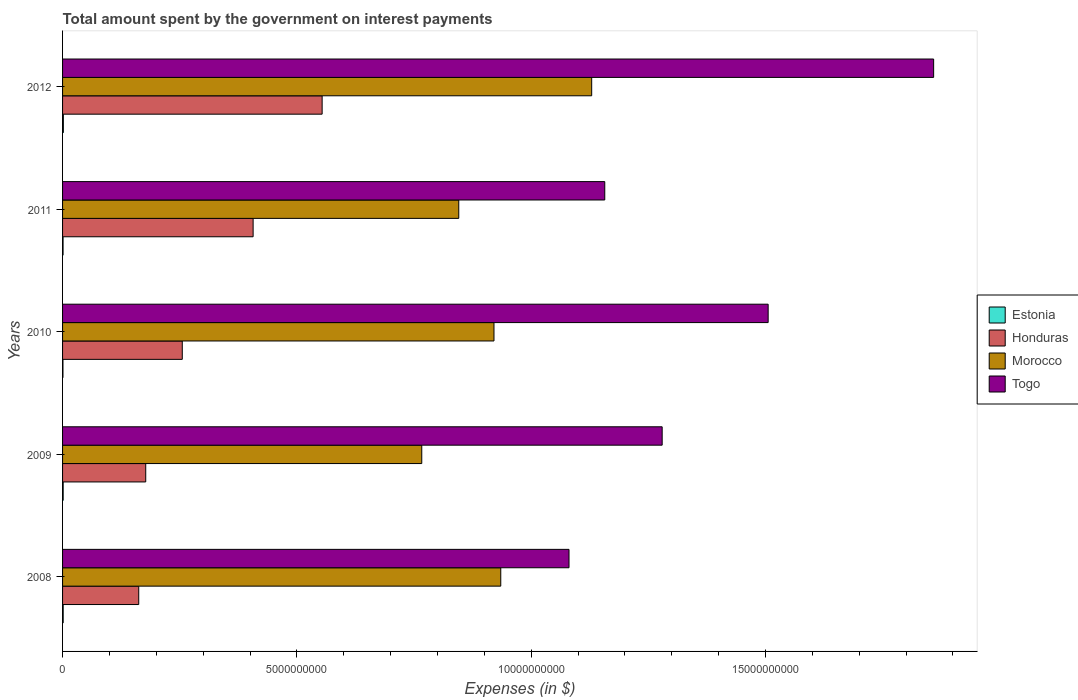How many different coloured bars are there?
Offer a terse response. 4. Are the number of bars per tick equal to the number of legend labels?
Ensure brevity in your answer.  Yes. Are the number of bars on each tick of the Y-axis equal?
Provide a short and direct response. Yes. How many bars are there on the 4th tick from the bottom?
Provide a short and direct response. 4. What is the label of the 4th group of bars from the top?
Offer a very short reply. 2009. In how many cases, is the number of bars for a given year not equal to the number of legend labels?
Provide a short and direct response. 0. What is the amount spent on interest payments by the government in Togo in 2012?
Keep it short and to the point. 1.86e+1. Across all years, what is the maximum amount spent on interest payments by the government in Morocco?
Your response must be concise. 1.13e+1. Across all years, what is the minimum amount spent on interest payments by the government in Estonia?
Provide a short and direct response. 8.20e+06. What is the total amount spent on interest payments by the government in Honduras in the graph?
Your response must be concise. 1.56e+1. What is the difference between the amount spent on interest payments by the government in Togo in 2009 and that in 2010?
Provide a short and direct response. -2.26e+09. What is the difference between the amount spent on interest payments by the government in Honduras in 2011 and the amount spent on interest payments by the government in Estonia in 2012?
Ensure brevity in your answer.  4.05e+09. What is the average amount spent on interest payments by the government in Morocco per year?
Make the answer very short. 9.19e+09. In the year 2011, what is the difference between the amount spent on interest payments by the government in Morocco and amount spent on interest payments by the government in Honduras?
Offer a very short reply. 4.39e+09. In how many years, is the amount spent on interest payments by the government in Morocco greater than 13000000000 $?
Ensure brevity in your answer.  0. What is the ratio of the amount spent on interest payments by the government in Morocco in 2010 to that in 2011?
Give a very brief answer. 1.09. Is the difference between the amount spent on interest payments by the government in Morocco in 2010 and 2011 greater than the difference between the amount spent on interest payments by the government in Honduras in 2010 and 2011?
Make the answer very short. Yes. What is the difference between the highest and the second highest amount spent on interest payments by the government in Togo?
Your answer should be compact. 3.53e+09. What is the difference between the highest and the lowest amount spent on interest payments by the government in Togo?
Provide a succinct answer. 7.78e+09. Is it the case that in every year, the sum of the amount spent on interest payments by the government in Morocco and amount spent on interest payments by the government in Togo is greater than the sum of amount spent on interest payments by the government in Estonia and amount spent on interest payments by the government in Honduras?
Offer a terse response. Yes. What does the 1st bar from the top in 2012 represents?
Offer a very short reply. Togo. What does the 4th bar from the bottom in 2012 represents?
Provide a succinct answer. Togo. How many bars are there?
Your answer should be compact. 20. How many years are there in the graph?
Make the answer very short. 5. Does the graph contain grids?
Your answer should be compact. No. What is the title of the graph?
Your answer should be very brief. Total amount spent by the government on interest payments. Does "Belize" appear as one of the legend labels in the graph?
Make the answer very short. No. What is the label or title of the X-axis?
Offer a terse response. Expenses (in $). What is the label or title of the Y-axis?
Ensure brevity in your answer.  Years. What is the Expenses (in $) in Estonia in 2008?
Keep it short and to the point. 1.32e+07. What is the Expenses (in $) of Honduras in 2008?
Offer a terse response. 1.63e+09. What is the Expenses (in $) in Morocco in 2008?
Make the answer very short. 9.35e+09. What is the Expenses (in $) in Togo in 2008?
Offer a very short reply. 1.08e+1. What is the Expenses (in $) of Estonia in 2009?
Make the answer very short. 1.28e+07. What is the Expenses (in $) of Honduras in 2009?
Make the answer very short. 1.77e+09. What is the Expenses (in $) of Morocco in 2009?
Offer a very short reply. 7.66e+09. What is the Expenses (in $) in Togo in 2009?
Provide a succinct answer. 1.28e+1. What is the Expenses (in $) of Estonia in 2010?
Keep it short and to the point. 8.20e+06. What is the Expenses (in $) in Honduras in 2010?
Give a very brief answer. 2.55e+09. What is the Expenses (in $) of Morocco in 2010?
Your answer should be compact. 9.21e+09. What is the Expenses (in $) of Togo in 2010?
Your response must be concise. 1.51e+1. What is the Expenses (in $) of Estonia in 2011?
Ensure brevity in your answer.  1.07e+07. What is the Expenses (in $) of Honduras in 2011?
Offer a very short reply. 4.07e+09. What is the Expenses (in $) of Morocco in 2011?
Your answer should be very brief. 8.45e+09. What is the Expenses (in $) of Togo in 2011?
Ensure brevity in your answer.  1.16e+1. What is the Expenses (in $) of Estonia in 2012?
Keep it short and to the point. 1.70e+07. What is the Expenses (in $) of Honduras in 2012?
Your answer should be compact. 5.54e+09. What is the Expenses (in $) of Morocco in 2012?
Keep it short and to the point. 1.13e+1. What is the Expenses (in $) of Togo in 2012?
Give a very brief answer. 1.86e+1. Across all years, what is the maximum Expenses (in $) of Estonia?
Offer a very short reply. 1.70e+07. Across all years, what is the maximum Expenses (in $) in Honduras?
Make the answer very short. 5.54e+09. Across all years, what is the maximum Expenses (in $) of Morocco?
Ensure brevity in your answer.  1.13e+1. Across all years, what is the maximum Expenses (in $) of Togo?
Your answer should be very brief. 1.86e+1. Across all years, what is the minimum Expenses (in $) in Estonia?
Ensure brevity in your answer.  8.20e+06. Across all years, what is the minimum Expenses (in $) of Honduras?
Your response must be concise. 1.63e+09. Across all years, what is the minimum Expenses (in $) in Morocco?
Make the answer very short. 7.66e+09. Across all years, what is the minimum Expenses (in $) in Togo?
Provide a succinct answer. 1.08e+1. What is the total Expenses (in $) in Estonia in the graph?
Your response must be concise. 6.19e+07. What is the total Expenses (in $) in Honduras in the graph?
Give a very brief answer. 1.56e+1. What is the total Expenses (in $) of Morocco in the graph?
Your response must be concise. 4.60e+1. What is the total Expenses (in $) of Togo in the graph?
Offer a very short reply. 6.88e+1. What is the difference between the Expenses (in $) in Estonia in 2008 and that in 2009?
Offer a terse response. 4.00e+05. What is the difference between the Expenses (in $) in Honduras in 2008 and that in 2009?
Your answer should be very brief. -1.49e+08. What is the difference between the Expenses (in $) of Morocco in 2008 and that in 2009?
Provide a succinct answer. 1.69e+09. What is the difference between the Expenses (in $) in Togo in 2008 and that in 2009?
Ensure brevity in your answer.  -1.99e+09. What is the difference between the Expenses (in $) of Honduras in 2008 and that in 2010?
Ensure brevity in your answer.  -9.29e+08. What is the difference between the Expenses (in $) in Morocco in 2008 and that in 2010?
Make the answer very short. 1.45e+08. What is the difference between the Expenses (in $) in Togo in 2008 and that in 2010?
Ensure brevity in your answer.  -4.25e+09. What is the difference between the Expenses (in $) of Estonia in 2008 and that in 2011?
Offer a terse response. 2.50e+06. What is the difference between the Expenses (in $) in Honduras in 2008 and that in 2011?
Offer a very short reply. -2.44e+09. What is the difference between the Expenses (in $) of Morocco in 2008 and that in 2011?
Your answer should be very brief. 8.96e+08. What is the difference between the Expenses (in $) in Togo in 2008 and that in 2011?
Provide a succinct answer. -7.63e+08. What is the difference between the Expenses (in $) in Estonia in 2008 and that in 2012?
Your response must be concise. -3.80e+06. What is the difference between the Expenses (in $) in Honduras in 2008 and that in 2012?
Provide a short and direct response. -3.91e+09. What is the difference between the Expenses (in $) in Morocco in 2008 and that in 2012?
Your answer should be compact. -1.94e+09. What is the difference between the Expenses (in $) of Togo in 2008 and that in 2012?
Keep it short and to the point. -7.78e+09. What is the difference between the Expenses (in $) of Estonia in 2009 and that in 2010?
Make the answer very short. 4.60e+06. What is the difference between the Expenses (in $) in Honduras in 2009 and that in 2010?
Your answer should be compact. -7.80e+08. What is the difference between the Expenses (in $) of Morocco in 2009 and that in 2010?
Ensure brevity in your answer.  -1.54e+09. What is the difference between the Expenses (in $) of Togo in 2009 and that in 2010?
Your answer should be compact. -2.26e+09. What is the difference between the Expenses (in $) in Estonia in 2009 and that in 2011?
Provide a short and direct response. 2.10e+06. What is the difference between the Expenses (in $) of Honduras in 2009 and that in 2011?
Make the answer very short. -2.29e+09. What is the difference between the Expenses (in $) of Morocco in 2009 and that in 2011?
Offer a very short reply. -7.90e+08. What is the difference between the Expenses (in $) of Togo in 2009 and that in 2011?
Give a very brief answer. 1.22e+09. What is the difference between the Expenses (in $) in Estonia in 2009 and that in 2012?
Keep it short and to the point. -4.20e+06. What is the difference between the Expenses (in $) of Honduras in 2009 and that in 2012?
Your answer should be very brief. -3.76e+09. What is the difference between the Expenses (in $) in Morocco in 2009 and that in 2012?
Your answer should be very brief. -3.63e+09. What is the difference between the Expenses (in $) of Togo in 2009 and that in 2012?
Provide a short and direct response. -5.79e+09. What is the difference between the Expenses (in $) in Estonia in 2010 and that in 2011?
Keep it short and to the point. -2.50e+06. What is the difference between the Expenses (in $) of Honduras in 2010 and that in 2011?
Your response must be concise. -1.51e+09. What is the difference between the Expenses (in $) in Morocco in 2010 and that in 2011?
Your answer should be very brief. 7.52e+08. What is the difference between the Expenses (in $) of Togo in 2010 and that in 2011?
Make the answer very short. 3.49e+09. What is the difference between the Expenses (in $) in Estonia in 2010 and that in 2012?
Your response must be concise. -8.80e+06. What is the difference between the Expenses (in $) in Honduras in 2010 and that in 2012?
Offer a terse response. -2.98e+09. What is the difference between the Expenses (in $) of Morocco in 2010 and that in 2012?
Your answer should be compact. -2.08e+09. What is the difference between the Expenses (in $) in Togo in 2010 and that in 2012?
Your answer should be compact. -3.53e+09. What is the difference between the Expenses (in $) in Estonia in 2011 and that in 2012?
Offer a terse response. -6.30e+06. What is the difference between the Expenses (in $) of Honduras in 2011 and that in 2012?
Your response must be concise. -1.47e+09. What is the difference between the Expenses (in $) of Morocco in 2011 and that in 2012?
Your answer should be compact. -2.84e+09. What is the difference between the Expenses (in $) in Togo in 2011 and that in 2012?
Provide a succinct answer. -7.02e+09. What is the difference between the Expenses (in $) of Estonia in 2008 and the Expenses (in $) of Honduras in 2009?
Offer a terse response. -1.76e+09. What is the difference between the Expenses (in $) in Estonia in 2008 and the Expenses (in $) in Morocco in 2009?
Offer a terse response. -7.65e+09. What is the difference between the Expenses (in $) in Estonia in 2008 and the Expenses (in $) in Togo in 2009?
Provide a succinct answer. -1.28e+1. What is the difference between the Expenses (in $) of Honduras in 2008 and the Expenses (in $) of Morocco in 2009?
Keep it short and to the point. -6.04e+09. What is the difference between the Expenses (in $) in Honduras in 2008 and the Expenses (in $) in Togo in 2009?
Your answer should be very brief. -1.12e+1. What is the difference between the Expenses (in $) of Morocco in 2008 and the Expenses (in $) of Togo in 2009?
Offer a very short reply. -3.44e+09. What is the difference between the Expenses (in $) of Estonia in 2008 and the Expenses (in $) of Honduras in 2010?
Offer a terse response. -2.54e+09. What is the difference between the Expenses (in $) in Estonia in 2008 and the Expenses (in $) in Morocco in 2010?
Keep it short and to the point. -9.19e+09. What is the difference between the Expenses (in $) in Estonia in 2008 and the Expenses (in $) in Togo in 2010?
Give a very brief answer. -1.50e+1. What is the difference between the Expenses (in $) in Honduras in 2008 and the Expenses (in $) in Morocco in 2010?
Ensure brevity in your answer.  -7.58e+09. What is the difference between the Expenses (in $) in Honduras in 2008 and the Expenses (in $) in Togo in 2010?
Your response must be concise. -1.34e+1. What is the difference between the Expenses (in $) in Morocco in 2008 and the Expenses (in $) in Togo in 2010?
Make the answer very short. -5.71e+09. What is the difference between the Expenses (in $) in Estonia in 2008 and the Expenses (in $) in Honduras in 2011?
Offer a terse response. -4.05e+09. What is the difference between the Expenses (in $) of Estonia in 2008 and the Expenses (in $) of Morocco in 2011?
Provide a succinct answer. -8.44e+09. What is the difference between the Expenses (in $) in Estonia in 2008 and the Expenses (in $) in Togo in 2011?
Your answer should be very brief. -1.16e+1. What is the difference between the Expenses (in $) of Honduras in 2008 and the Expenses (in $) of Morocco in 2011?
Ensure brevity in your answer.  -6.83e+09. What is the difference between the Expenses (in $) in Honduras in 2008 and the Expenses (in $) in Togo in 2011?
Offer a terse response. -9.94e+09. What is the difference between the Expenses (in $) of Morocco in 2008 and the Expenses (in $) of Togo in 2011?
Provide a short and direct response. -2.22e+09. What is the difference between the Expenses (in $) in Estonia in 2008 and the Expenses (in $) in Honduras in 2012?
Your answer should be very brief. -5.53e+09. What is the difference between the Expenses (in $) of Estonia in 2008 and the Expenses (in $) of Morocco in 2012?
Make the answer very short. -1.13e+1. What is the difference between the Expenses (in $) of Estonia in 2008 and the Expenses (in $) of Togo in 2012?
Provide a short and direct response. -1.86e+1. What is the difference between the Expenses (in $) of Honduras in 2008 and the Expenses (in $) of Morocco in 2012?
Offer a terse response. -9.67e+09. What is the difference between the Expenses (in $) in Honduras in 2008 and the Expenses (in $) in Togo in 2012?
Provide a succinct answer. -1.70e+1. What is the difference between the Expenses (in $) in Morocco in 2008 and the Expenses (in $) in Togo in 2012?
Offer a very short reply. -9.24e+09. What is the difference between the Expenses (in $) in Estonia in 2009 and the Expenses (in $) in Honduras in 2010?
Make the answer very short. -2.54e+09. What is the difference between the Expenses (in $) of Estonia in 2009 and the Expenses (in $) of Morocco in 2010?
Provide a short and direct response. -9.19e+09. What is the difference between the Expenses (in $) of Estonia in 2009 and the Expenses (in $) of Togo in 2010?
Offer a terse response. -1.50e+1. What is the difference between the Expenses (in $) of Honduras in 2009 and the Expenses (in $) of Morocco in 2010?
Offer a very short reply. -7.43e+09. What is the difference between the Expenses (in $) of Honduras in 2009 and the Expenses (in $) of Togo in 2010?
Offer a terse response. -1.33e+1. What is the difference between the Expenses (in $) in Morocco in 2009 and the Expenses (in $) in Togo in 2010?
Your response must be concise. -7.39e+09. What is the difference between the Expenses (in $) in Estonia in 2009 and the Expenses (in $) in Honduras in 2011?
Your response must be concise. -4.05e+09. What is the difference between the Expenses (in $) of Estonia in 2009 and the Expenses (in $) of Morocco in 2011?
Keep it short and to the point. -8.44e+09. What is the difference between the Expenses (in $) in Estonia in 2009 and the Expenses (in $) in Togo in 2011?
Make the answer very short. -1.16e+1. What is the difference between the Expenses (in $) in Honduras in 2009 and the Expenses (in $) in Morocco in 2011?
Offer a very short reply. -6.68e+09. What is the difference between the Expenses (in $) in Honduras in 2009 and the Expenses (in $) in Togo in 2011?
Provide a succinct answer. -9.80e+09. What is the difference between the Expenses (in $) of Morocco in 2009 and the Expenses (in $) of Togo in 2011?
Your response must be concise. -3.91e+09. What is the difference between the Expenses (in $) of Estonia in 2009 and the Expenses (in $) of Honduras in 2012?
Your response must be concise. -5.53e+09. What is the difference between the Expenses (in $) in Estonia in 2009 and the Expenses (in $) in Morocco in 2012?
Offer a terse response. -1.13e+1. What is the difference between the Expenses (in $) in Estonia in 2009 and the Expenses (in $) in Togo in 2012?
Your answer should be very brief. -1.86e+1. What is the difference between the Expenses (in $) of Honduras in 2009 and the Expenses (in $) of Morocco in 2012?
Offer a very short reply. -9.52e+09. What is the difference between the Expenses (in $) of Honduras in 2009 and the Expenses (in $) of Togo in 2012?
Provide a short and direct response. -1.68e+1. What is the difference between the Expenses (in $) of Morocco in 2009 and the Expenses (in $) of Togo in 2012?
Make the answer very short. -1.09e+1. What is the difference between the Expenses (in $) in Estonia in 2010 and the Expenses (in $) in Honduras in 2011?
Offer a terse response. -4.06e+09. What is the difference between the Expenses (in $) in Estonia in 2010 and the Expenses (in $) in Morocco in 2011?
Give a very brief answer. -8.45e+09. What is the difference between the Expenses (in $) of Estonia in 2010 and the Expenses (in $) of Togo in 2011?
Provide a short and direct response. -1.16e+1. What is the difference between the Expenses (in $) in Honduras in 2010 and the Expenses (in $) in Morocco in 2011?
Your answer should be very brief. -5.90e+09. What is the difference between the Expenses (in $) of Honduras in 2010 and the Expenses (in $) of Togo in 2011?
Offer a terse response. -9.02e+09. What is the difference between the Expenses (in $) of Morocco in 2010 and the Expenses (in $) of Togo in 2011?
Offer a very short reply. -2.36e+09. What is the difference between the Expenses (in $) in Estonia in 2010 and the Expenses (in $) in Honduras in 2012?
Your answer should be very brief. -5.53e+09. What is the difference between the Expenses (in $) in Estonia in 2010 and the Expenses (in $) in Morocco in 2012?
Ensure brevity in your answer.  -1.13e+1. What is the difference between the Expenses (in $) in Estonia in 2010 and the Expenses (in $) in Togo in 2012?
Your answer should be very brief. -1.86e+1. What is the difference between the Expenses (in $) of Honduras in 2010 and the Expenses (in $) of Morocco in 2012?
Give a very brief answer. -8.74e+09. What is the difference between the Expenses (in $) in Honduras in 2010 and the Expenses (in $) in Togo in 2012?
Your response must be concise. -1.60e+1. What is the difference between the Expenses (in $) of Morocco in 2010 and the Expenses (in $) of Togo in 2012?
Your answer should be compact. -9.38e+09. What is the difference between the Expenses (in $) in Estonia in 2011 and the Expenses (in $) in Honduras in 2012?
Keep it short and to the point. -5.53e+09. What is the difference between the Expenses (in $) in Estonia in 2011 and the Expenses (in $) in Morocco in 2012?
Ensure brevity in your answer.  -1.13e+1. What is the difference between the Expenses (in $) in Estonia in 2011 and the Expenses (in $) in Togo in 2012?
Make the answer very short. -1.86e+1. What is the difference between the Expenses (in $) in Honduras in 2011 and the Expenses (in $) in Morocco in 2012?
Provide a succinct answer. -7.22e+09. What is the difference between the Expenses (in $) of Honduras in 2011 and the Expenses (in $) of Togo in 2012?
Make the answer very short. -1.45e+1. What is the difference between the Expenses (in $) in Morocco in 2011 and the Expenses (in $) in Togo in 2012?
Offer a very short reply. -1.01e+1. What is the average Expenses (in $) of Estonia per year?
Make the answer very short. 1.24e+07. What is the average Expenses (in $) of Honduras per year?
Give a very brief answer. 3.11e+09. What is the average Expenses (in $) in Morocco per year?
Ensure brevity in your answer.  9.19e+09. What is the average Expenses (in $) of Togo per year?
Your answer should be very brief. 1.38e+1. In the year 2008, what is the difference between the Expenses (in $) of Estonia and Expenses (in $) of Honduras?
Provide a succinct answer. -1.61e+09. In the year 2008, what is the difference between the Expenses (in $) in Estonia and Expenses (in $) in Morocco?
Offer a very short reply. -9.34e+09. In the year 2008, what is the difference between the Expenses (in $) of Estonia and Expenses (in $) of Togo?
Keep it short and to the point. -1.08e+1. In the year 2008, what is the difference between the Expenses (in $) of Honduras and Expenses (in $) of Morocco?
Your response must be concise. -7.73e+09. In the year 2008, what is the difference between the Expenses (in $) of Honduras and Expenses (in $) of Togo?
Keep it short and to the point. -9.18e+09. In the year 2008, what is the difference between the Expenses (in $) in Morocco and Expenses (in $) in Togo?
Your answer should be very brief. -1.46e+09. In the year 2009, what is the difference between the Expenses (in $) of Estonia and Expenses (in $) of Honduras?
Offer a terse response. -1.76e+09. In the year 2009, what is the difference between the Expenses (in $) of Estonia and Expenses (in $) of Morocco?
Your response must be concise. -7.65e+09. In the year 2009, what is the difference between the Expenses (in $) of Estonia and Expenses (in $) of Togo?
Provide a short and direct response. -1.28e+1. In the year 2009, what is the difference between the Expenses (in $) of Honduras and Expenses (in $) of Morocco?
Your response must be concise. -5.89e+09. In the year 2009, what is the difference between the Expenses (in $) of Honduras and Expenses (in $) of Togo?
Make the answer very short. -1.10e+1. In the year 2009, what is the difference between the Expenses (in $) of Morocco and Expenses (in $) of Togo?
Provide a short and direct response. -5.13e+09. In the year 2010, what is the difference between the Expenses (in $) of Estonia and Expenses (in $) of Honduras?
Your answer should be compact. -2.55e+09. In the year 2010, what is the difference between the Expenses (in $) of Estonia and Expenses (in $) of Morocco?
Make the answer very short. -9.20e+09. In the year 2010, what is the difference between the Expenses (in $) of Estonia and Expenses (in $) of Togo?
Give a very brief answer. -1.50e+1. In the year 2010, what is the difference between the Expenses (in $) of Honduras and Expenses (in $) of Morocco?
Provide a short and direct response. -6.65e+09. In the year 2010, what is the difference between the Expenses (in $) of Honduras and Expenses (in $) of Togo?
Ensure brevity in your answer.  -1.25e+1. In the year 2010, what is the difference between the Expenses (in $) in Morocco and Expenses (in $) in Togo?
Offer a terse response. -5.85e+09. In the year 2011, what is the difference between the Expenses (in $) in Estonia and Expenses (in $) in Honduras?
Keep it short and to the point. -4.06e+09. In the year 2011, what is the difference between the Expenses (in $) of Estonia and Expenses (in $) of Morocco?
Your answer should be very brief. -8.44e+09. In the year 2011, what is the difference between the Expenses (in $) of Estonia and Expenses (in $) of Togo?
Ensure brevity in your answer.  -1.16e+1. In the year 2011, what is the difference between the Expenses (in $) in Honduras and Expenses (in $) in Morocco?
Give a very brief answer. -4.39e+09. In the year 2011, what is the difference between the Expenses (in $) in Honduras and Expenses (in $) in Togo?
Your response must be concise. -7.50e+09. In the year 2011, what is the difference between the Expenses (in $) of Morocco and Expenses (in $) of Togo?
Offer a very short reply. -3.12e+09. In the year 2012, what is the difference between the Expenses (in $) of Estonia and Expenses (in $) of Honduras?
Provide a short and direct response. -5.52e+09. In the year 2012, what is the difference between the Expenses (in $) of Estonia and Expenses (in $) of Morocco?
Offer a terse response. -1.13e+1. In the year 2012, what is the difference between the Expenses (in $) in Estonia and Expenses (in $) in Togo?
Keep it short and to the point. -1.86e+1. In the year 2012, what is the difference between the Expenses (in $) of Honduras and Expenses (in $) of Morocco?
Your answer should be compact. -5.75e+09. In the year 2012, what is the difference between the Expenses (in $) of Honduras and Expenses (in $) of Togo?
Your answer should be very brief. -1.30e+1. In the year 2012, what is the difference between the Expenses (in $) of Morocco and Expenses (in $) of Togo?
Offer a terse response. -7.30e+09. What is the ratio of the Expenses (in $) in Estonia in 2008 to that in 2009?
Your response must be concise. 1.03. What is the ratio of the Expenses (in $) of Honduras in 2008 to that in 2009?
Provide a succinct answer. 0.92. What is the ratio of the Expenses (in $) in Morocco in 2008 to that in 2009?
Offer a very short reply. 1.22. What is the ratio of the Expenses (in $) of Togo in 2008 to that in 2009?
Make the answer very short. 0.84. What is the ratio of the Expenses (in $) in Estonia in 2008 to that in 2010?
Offer a terse response. 1.61. What is the ratio of the Expenses (in $) of Honduras in 2008 to that in 2010?
Offer a very short reply. 0.64. What is the ratio of the Expenses (in $) of Morocco in 2008 to that in 2010?
Offer a terse response. 1.02. What is the ratio of the Expenses (in $) in Togo in 2008 to that in 2010?
Provide a short and direct response. 0.72. What is the ratio of the Expenses (in $) in Estonia in 2008 to that in 2011?
Your response must be concise. 1.23. What is the ratio of the Expenses (in $) of Honduras in 2008 to that in 2011?
Your response must be concise. 0.4. What is the ratio of the Expenses (in $) of Morocco in 2008 to that in 2011?
Make the answer very short. 1.11. What is the ratio of the Expenses (in $) of Togo in 2008 to that in 2011?
Provide a short and direct response. 0.93. What is the ratio of the Expenses (in $) in Estonia in 2008 to that in 2012?
Your answer should be compact. 0.78. What is the ratio of the Expenses (in $) of Honduras in 2008 to that in 2012?
Your answer should be very brief. 0.29. What is the ratio of the Expenses (in $) in Morocco in 2008 to that in 2012?
Provide a succinct answer. 0.83. What is the ratio of the Expenses (in $) in Togo in 2008 to that in 2012?
Give a very brief answer. 0.58. What is the ratio of the Expenses (in $) in Estonia in 2009 to that in 2010?
Offer a terse response. 1.56. What is the ratio of the Expenses (in $) of Honduras in 2009 to that in 2010?
Ensure brevity in your answer.  0.69. What is the ratio of the Expenses (in $) of Morocco in 2009 to that in 2010?
Your response must be concise. 0.83. What is the ratio of the Expenses (in $) of Togo in 2009 to that in 2010?
Your answer should be compact. 0.85. What is the ratio of the Expenses (in $) of Estonia in 2009 to that in 2011?
Give a very brief answer. 1.2. What is the ratio of the Expenses (in $) in Honduras in 2009 to that in 2011?
Your response must be concise. 0.44. What is the ratio of the Expenses (in $) of Morocco in 2009 to that in 2011?
Give a very brief answer. 0.91. What is the ratio of the Expenses (in $) of Togo in 2009 to that in 2011?
Provide a succinct answer. 1.11. What is the ratio of the Expenses (in $) of Estonia in 2009 to that in 2012?
Offer a terse response. 0.75. What is the ratio of the Expenses (in $) of Honduras in 2009 to that in 2012?
Provide a short and direct response. 0.32. What is the ratio of the Expenses (in $) of Morocco in 2009 to that in 2012?
Keep it short and to the point. 0.68. What is the ratio of the Expenses (in $) in Togo in 2009 to that in 2012?
Your answer should be very brief. 0.69. What is the ratio of the Expenses (in $) of Estonia in 2010 to that in 2011?
Make the answer very short. 0.77. What is the ratio of the Expenses (in $) in Honduras in 2010 to that in 2011?
Your answer should be very brief. 0.63. What is the ratio of the Expenses (in $) in Morocco in 2010 to that in 2011?
Your answer should be compact. 1.09. What is the ratio of the Expenses (in $) in Togo in 2010 to that in 2011?
Offer a terse response. 1.3. What is the ratio of the Expenses (in $) of Estonia in 2010 to that in 2012?
Offer a terse response. 0.48. What is the ratio of the Expenses (in $) in Honduras in 2010 to that in 2012?
Make the answer very short. 0.46. What is the ratio of the Expenses (in $) in Morocco in 2010 to that in 2012?
Offer a terse response. 0.82. What is the ratio of the Expenses (in $) in Togo in 2010 to that in 2012?
Ensure brevity in your answer.  0.81. What is the ratio of the Expenses (in $) in Estonia in 2011 to that in 2012?
Your answer should be very brief. 0.63. What is the ratio of the Expenses (in $) of Honduras in 2011 to that in 2012?
Provide a succinct answer. 0.73. What is the ratio of the Expenses (in $) of Morocco in 2011 to that in 2012?
Your answer should be compact. 0.75. What is the ratio of the Expenses (in $) in Togo in 2011 to that in 2012?
Make the answer very short. 0.62. What is the difference between the highest and the second highest Expenses (in $) of Estonia?
Make the answer very short. 3.80e+06. What is the difference between the highest and the second highest Expenses (in $) in Honduras?
Offer a very short reply. 1.47e+09. What is the difference between the highest and the second highest Expenses (in $) in Morocco?
Ensure brevity in your answer.  1.94e+09. What is the difference between the highest and the second highest Expenses (in $) of Togo?
Your response must be concise. 3.53e+09. What is the difference between the highest and the lowest Expenses (in $) in Estonia?
Give a very brief answer. 8.80e+06. What is the difference between the highest and the lowest Expenses (in $) in Honduras?
Your answer should be very brief. 3.91e+09. What is the difference between the highest and the lowest Expenses (in $) in Morocco?
Your answer should be compact. 3.63e+09. What is the difference between the highest and the lowest Expenses (in $) in Togo?
Make the answer very short. 7.78e+09. 